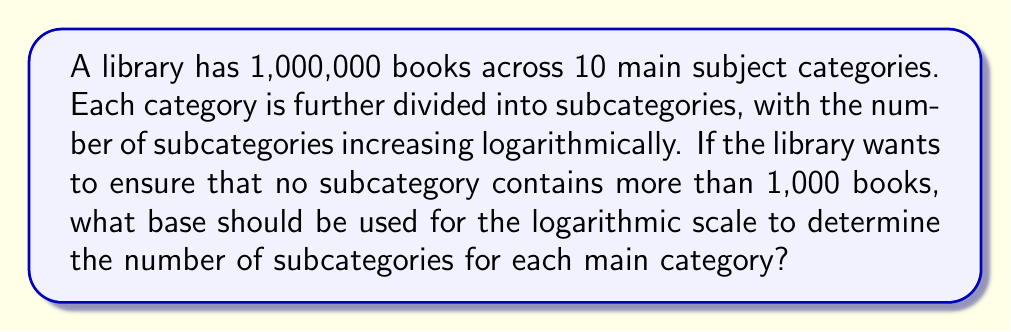Solve this math problem. Let's approach this step-by-step:

1) We know there are 1,000,000 books in total and 10 main categories.

2) Assuming an equal distribution, each main category would have:
   $\frac{1,000,000}{10} = 100,000$ books

3) We want each subcategory to have no more than 1,000 books. So, we need to find how many subcategories are needed to divide 100,000 books into groups of 1,000 or fewer.

4) Let $x$ be the number of subcategories. We can express this as:
   $\frac{100,000}{x} \leq 1,000$

5) Solving for $x$:
   $x \geq \frac{100,000}{1,000} = 100$

6) Now, we want to express this logarithmically. Let $b$ be the base we're looking for:
   $\log_b(100,000) = 2$  (since we want 2 levels: main categories and subcategories)

7) Using the change of base formula:
   $\frac{\log(100,000)}{\log(b)} = 2$

8) Solving for $b$:
   $\log(b) = \frac{\log(100,000)}{2}$
   $b = 10^{\frac{\log(100,000)}{2}} \approx 316.23$

9) Since we need at least 100 subcategories (from step 5), and $\log_{316.23}(100,000) = 2$, this base satisfies our requirements.
Answer: $316.23$ 